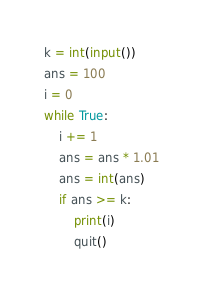Convert code to text. <code><loc_0><loc_0><loc_500><loc_500><_Python_>k = int(input())
ans = 100
i = 0
while True:
    i += 1
    ans = ans * 1.01 
    ans = int(ans)
    if ans >= k:
        print(i)
        quit()

</code> 